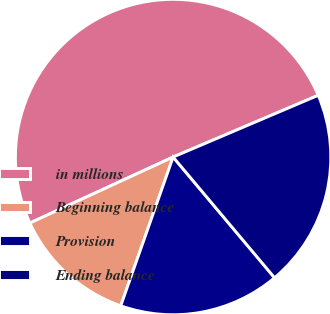<chart> <loc_0><loc_0><loc_500><loc_500><pie_chart><fcel>in millions<fcel>Beginning balance<fcel>Provision<fcel>Ending balance<nl><fcel>50.47%<fcel>12.74%<fcel>16.51%<fcel>20.28%<nl></chart> 